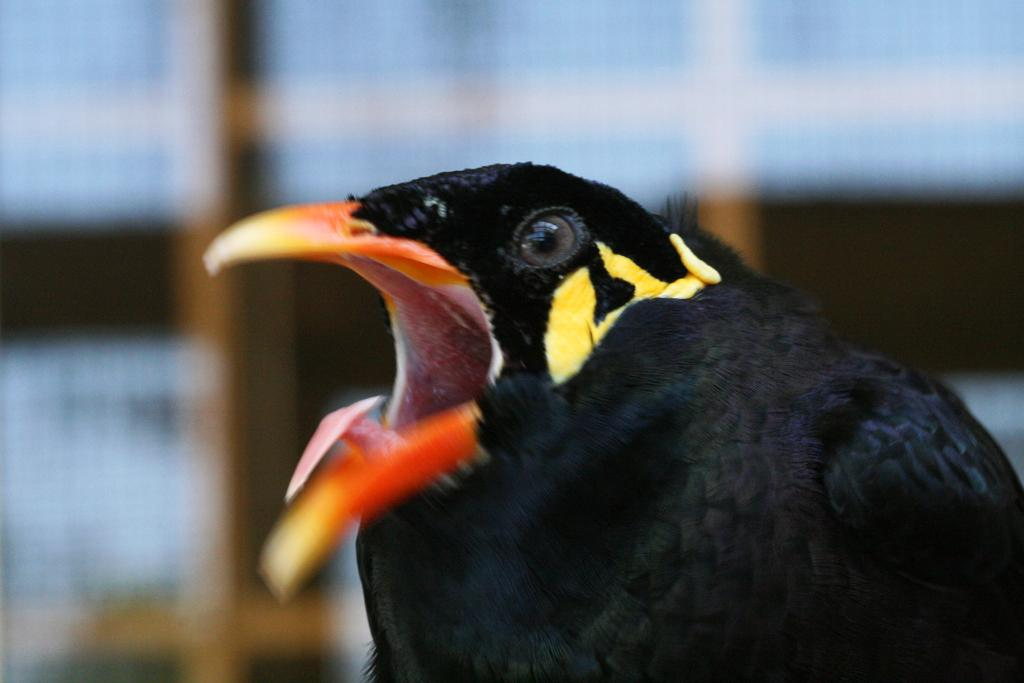What type of bird can be seen in the image? There is a black color bird in the image. What is the bird doing in the image? The bird's mouth is open. Can you describe the background of the image? The background of the image is blurry. What type of credit card is the bird holding in the image? There is no credit card present in the image; it features a black color bird with its mouth open against a blurry background. 